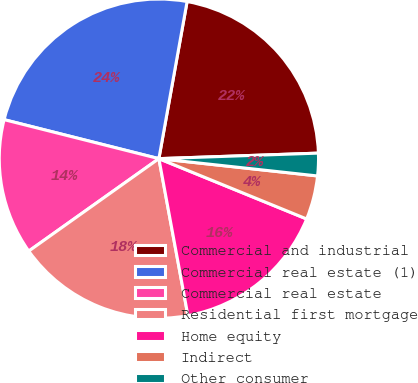<chart> <loc_0><loc_0><loc_500><loc_500><pie_chart><fcel>Commercial and industrial<fcel>Commercial real estate (1)<fcel>Commercial real estate<fcel>Residential first mortgage<fcel>Home equity<fcel>Indirect<fcel>Other consumer<nl><fcel>21.62%<fcel>23.9%<fcel>13.76%<fcel>18.08%<fcel>15.92%<fcel>4.44%<fcel>2.28%<nl></chart> 